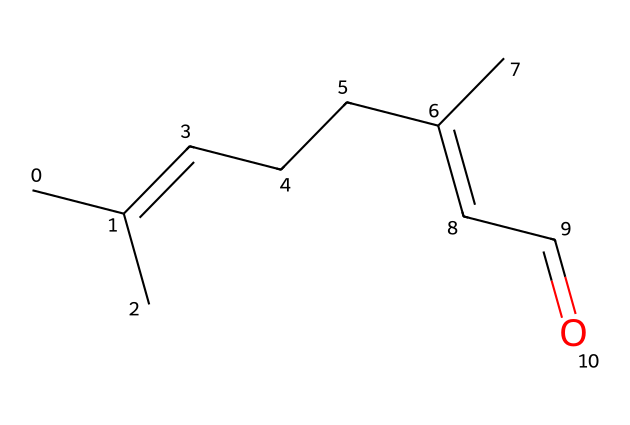What is the molecular formula of citral? To determine the molecular formula, we can count the number of carbon (C), hydrogen (H), and oxygen (O) atoms in the SMILES representation. There are 10 carbon atoms, 16 hydrogen atoms, and 1 oxygen atom. Therefore, the molecular formula is C10H16O.
Answer: C10H16O How many double bonds are present in citral? By analyzing the SMILES representation, we can identify the occurrences of double bonds indicated by '='. Counting these, we find a total of 2 double bonds in the citral structure.
Answer: 2 What type of functional group is present in citral? The presence of the carbonyl group (C=O) at the end of the carbon chain signifies that citral is an aldehyde. This is characteristic of aldehydes, which have the functional group -CHO.
Answer: aldehyde Does citral contain a chiral center? To assess chirality, we need to identify any carbon atom attached to four different substituents. In this case, there is one carbon atom which has different groups attached to it, making it a chiral center.
Answer: yes What is the main characteristic of aldehydes like citral in terms of reactivity? Aldehydes are typically reactive due to the polar nature of the carbonyl group, which makes them susceptible to nucleophilic attack. Therefore, they can easily undergo oxidation and reduction reactions.
Answer: reactive What type of isomerism can citral exhibit? Citral can exhibit geometric isomerism due to the presence of double bonds in its structure. The double bonds create the possibility for different arrangements of atoms around the bonds, leading to cis-trans isomerism.
Answer: geometric isomerism 